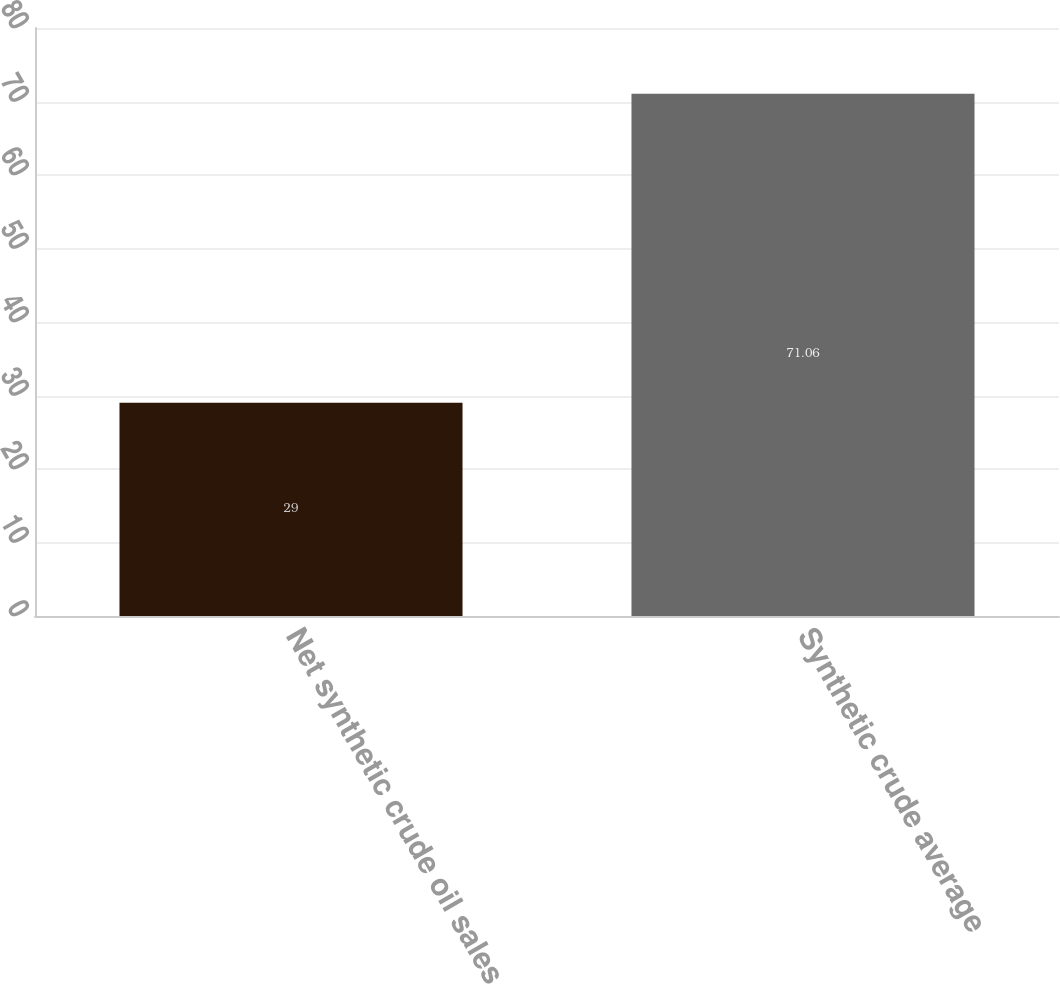<chart> <loc_0><loc_0><loc_500><loc_500><bar_chart><fcel>Net synthetic crude oil sales<fcel>Synthetic crude average<nl><fcel>29<fcel>71.06<nl></chart> 